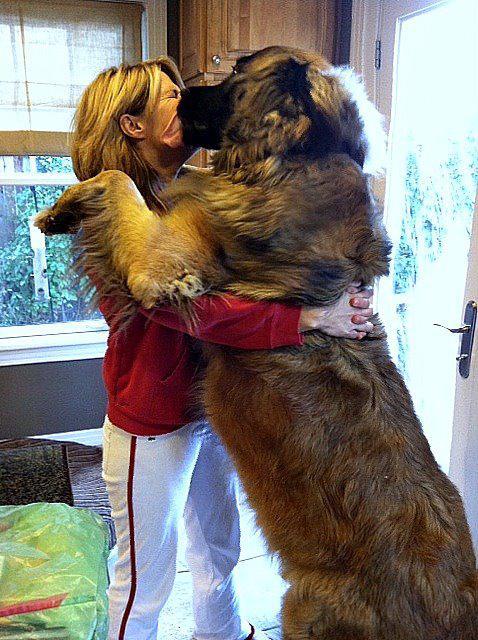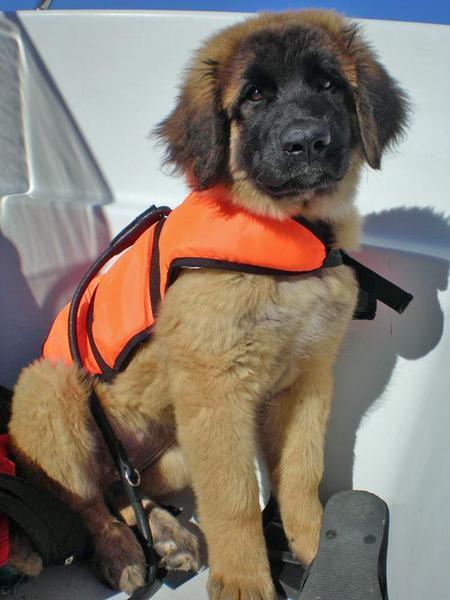The first image is the image on the left, the second image is the image on the right. Given the left and right images, does the statement "A person stands face-to-face with arms around a big standing dog." hold true? Answer yes or no. Yes. The first image is the image on the left, the second image is the image on the right. Evaluate the accuracy of this statement regarding the images: "A dog is hugging a human in one of the images.". Is it true? Answer yes or no. Yes. 